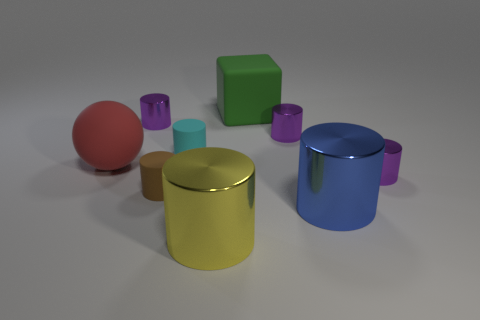Subtract all yellow balls. How many purple cylinders are left? 3 Subtract 3 cylinders. How many cylinders are left? 4 Subtract all brown cylinders. How many cylinders are left? 6 Subtract all purple cylinders. How many cylinders are left? 4 Subtract all red cylinders. Subtract all purple cubes. How many cylinders are left? 7 Add 1 tiny brown matte cylinders. How many objects exist? 10 Subtract all cylinders. How many objects are left? 2 Add 5 red things. How many red things are left? 6 Add 2 large yellow cylinders. How many large yellow cylinders exist? 3 Subtract 1 cyan cylinders. How many objects are left? 8 